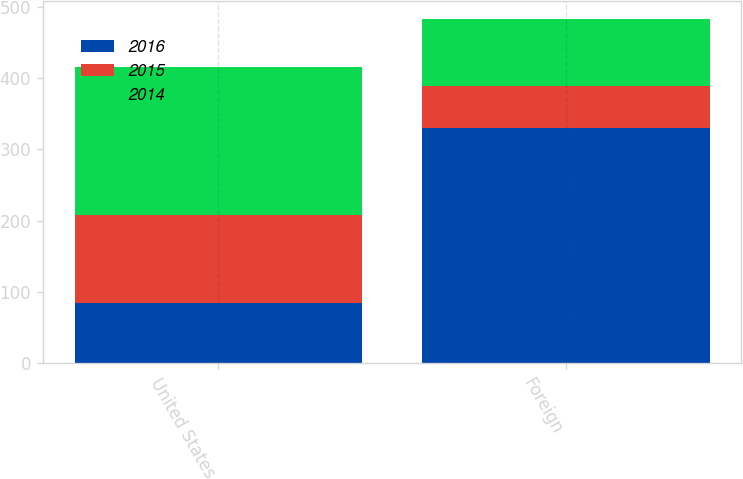<chart> <loc_0><loc_0><loc_500><loc_500><stacked_bar_chart><ecel><fcel>United States<fcel>Foreign<nl><fcel>2016<fcel>84<fcel>330<nl><fcel>2015<fcel>124<fcel>59<nl><fcel>2014<fcel>207<fcel>94<nl></chart> 